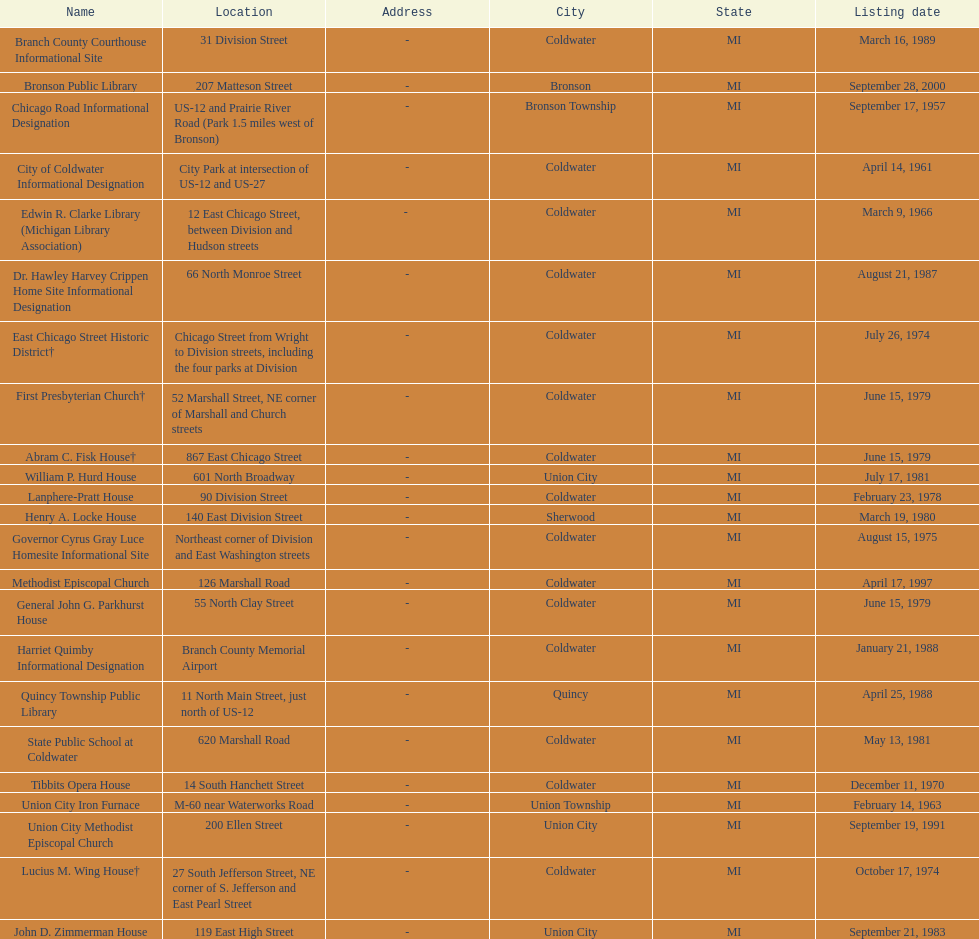How many historic sites were listed before 1965? 3. 